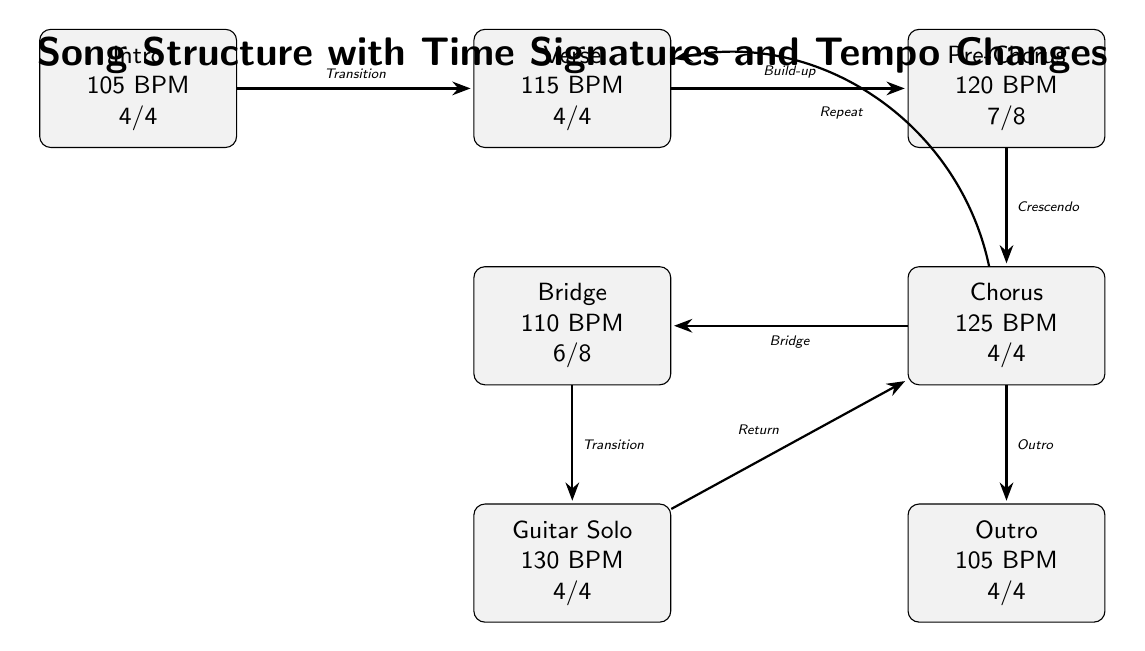What are the time signatures for the verse? Referring to the verse node in the diagram, it indicates that the time signature is 4/4.
Answer: 4/4 How many sections are there in the song structure? By counting the nodes representing the different song parts, there are a total of 7 sections: Intro, Verse, Pre-Chorus, Chorus, Bridge, Guitar Solo, and Outro.
Answer: 7 What is the tempo of the chorus? Checking the chorus node reveals that the tempo is marked at 125 BPM.
Answer: 125 BPM Which section has a tempo of 130 BPM? Looking at the nodes, the Guitar Solo is specifically noted with a tempo of 130 BPM.
Answer: Guitar Solo What transition connects the pre-chorus to the chorus? The diagram shows that the transition from the pre-chorus to the chorus is labeled as "Crescendo".
Answer: Crescendo What is the time signature in the bridge? The bridge node specifies that its time signature is 6/8.
Answer: 6/8 Which section has the longest tempo among the sections listed? The section with the highest tempo is the Guitar Solo, which is 130 BPM, making it the longest tempo in comparison to the others.
Answer: Guitar Solo How does the flow go from the chorus to the outro? The diagram illustrates a direct transition from the chorus to the outro labeled as "Outro".
Answer: Outro 